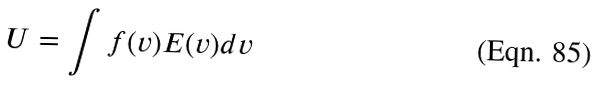<formula> <loc_0><loc_0><loc_500><loc_500>U = \int f ( v ) E ( v ) d v</formula> 